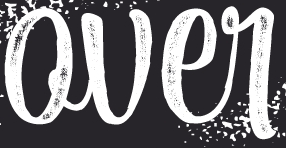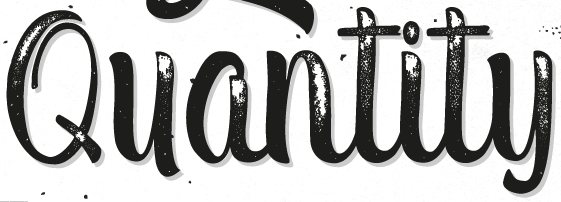What text is displayed in these images sequentially, separated by a semicolon? Qver; Quantity 